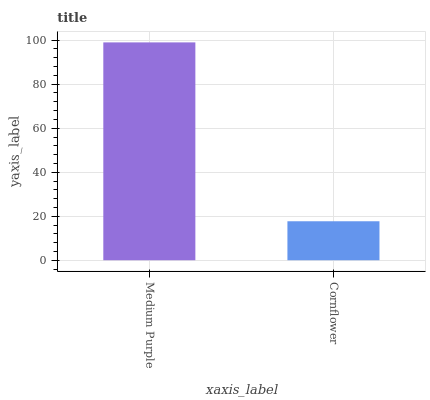Is Cornflower the minimum?
Answer yes or no. Yes. Is Medium Purple the maximum?
Answer yes or no. Yes. Is Cornflower the maximum?
Answer yes or no. No. Is Medium Purple greater than Cornflower?
Answer yes or no. Yes. Is Cornflower less than Medium Purple?
Answer yes or no. Yes. Is Cornflower greater than Medium Purple?
Answer yes or no. No. Is Medium Purple less than Cornflower?
Answer yes or no. No. Is Medium Purple the high median?
Answer yes or no. Yes. Is Cornflower the low median?
Answer yes or no. Yes. Is Cornflower the high median?
Answer yes or no. No. Is Medium Purple the low median?
Answer yes or no. No. 